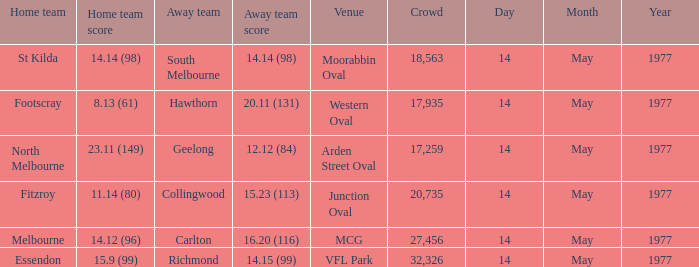What was the number of individuals in the crowd when the away team was collingwood? 1.0. Could you help me parse every detail presented in this table? {'header': ['Home team', 'Home team score', 'Away team', 'Away team score', 'Venue', 'Crowd', 'Day', 'Month', 'Year'], 'rows': [['St Kilda', '14.14 (98)', 'South Melbourne', '14.14 (98)', 'Moorabbin Oval', '18,563', '14', 'May', '1977'], ['Footscray', '8.13 (61)', 'Hawthorn', '20.11 (131)', 'Western Oval', '17,935', '14', 'May', '1977'], ['North Melbourne', '23.11 (149)', 'Geelong', '12.12 (84)', 'Arden Street Oval', '17,259', '14', 'May', '1977'], ['Fitzroy', '11.14 (80)', 'Collingwood', '15.23 (113)', 'Junction Oval', '20,735', '14', 'May', '1977'], ['Melbourne', '14.12 (96)', 'Carlton', '16.20 (116)', 'MCG', '27,456', '14', 'May', '1977'], ['Essendon', '15.9 (99)', 'Richmond', '14.15 (99)', 'VFL Park', '32,326', '14', 'May', '1977']]} 